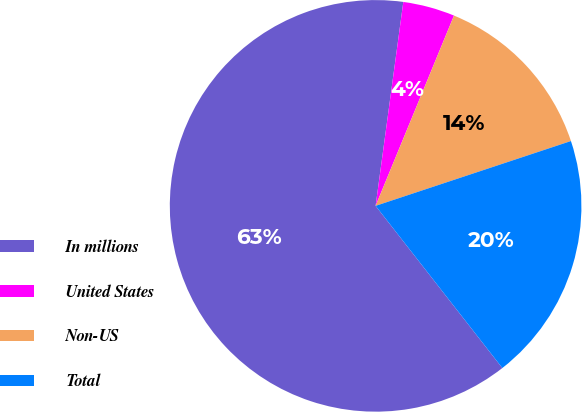Convert chart. <chart><loc_0><loc_0><loc_500><loc_500><pie_chart><fcel>In millions<fcel>United States<fcel>Non-US<fcel>Total<nl><fcel>62.7%<fcel>4.07%<fcel>13.68%<fcel>19.54%<nl></chart> 